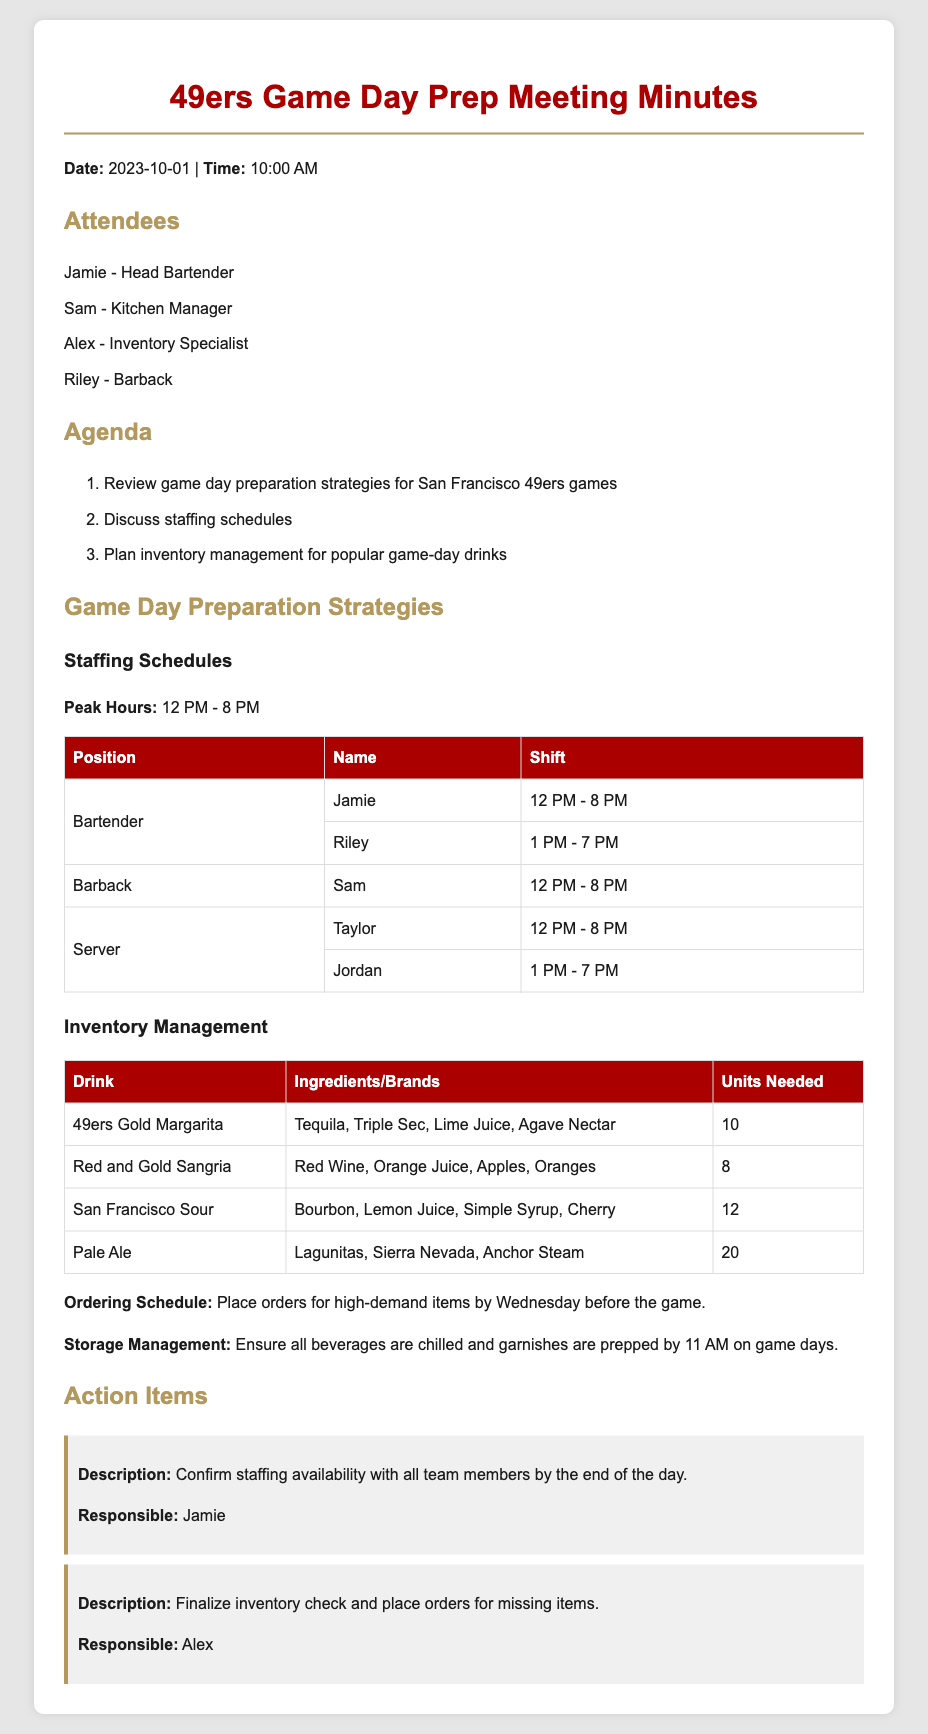What is the date of the meeting? The date of the meeting is specified at the beginning of the document.
Answer: 2023-10-01 Who is responsible for confirming staffing availability? The action item outlines that Jamie is responsible for this task.
Answer: Jamie What time does Jamie's shift start? The staffing schedule lists Jamie's shift starting time.
Answer: 12 PM How many units of Pale Ale are needed? The inventory management section specifies the units needed for Pale Ale.
Answer: 20 What drink requires bourbon as an ingredient? The inventory table indicates which drinks include bourbon.
Answer: San Francisco Sour What are the peak hours mentioned in the document? The document explicitly states the peak hours for game day activities.
Answer: 12 PM - 8 PM What is the preferred ordering schedule for high-demand items? The document details when to place orders for high-demand items.
Answer: Wednesday before the game How many servers are scheduled to work on game day? The staffing schedule shows the number of servers working.
Answer: 2 What is the main agenda item for the meeting? The first item in the agenda outlines the primary focus of the meeting.
Answer: Review game day preparation strategies for San Francisco 49ers games What is Alex responsible for regarding inventory? The action items discuss what Alex needs to finalize concerning inventory.
Answer: Finalize inventory check and place orders for missing items 